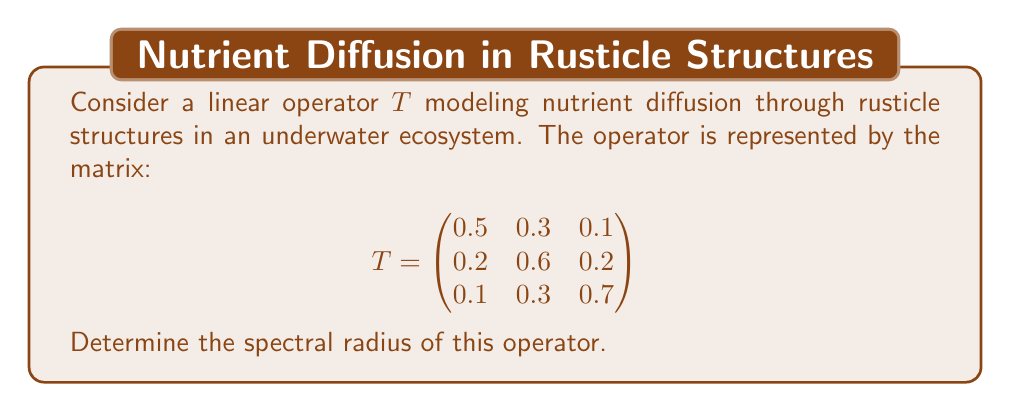Can you solve this math problem? To find the spectral radius of the linear operator $T$, we follow these steps:

1) The spectral radius is the maximum of the absolute values of the eigenvalues of $T$.

2) To find the eigenvalues, we solve the characteristic equation:
   $$\det(T - \lambda I) = 0$$

3) Expanding this determinant:
   $$\begin{vmatrix}
   0.5-\lambda & 0.3 & 0.1 \\
   0.2 & 0.6-\lambda & 0.2 \\
   0.1 & 0.3 & 0.7-\lambda
   \end{vmatrix} = 0$$

4) This expands to:
   $$(0.5-\lambda)(0.6-\lambda)(0.7-\lambda) - 0.3 \cdot 0.2 \cdot 0.1 - 0.1 \cdot 0.2 \cdot 0.3 - (0.5-\lambda) \cdot 0.2 \cdot 0.3 - 0.1 \cdot (0.6-\lambda) \cdot 0.1 - 0.3 \cdot 0.2 \cdot (0.7-\lambda) = 0$$

5) Simplifying:
   $$-\lambda^3 + 1.8\lambda^2 - 0.98\lambda + 0.162 = 0$$

6) This cubic equation can be solved using numerical methods. The eigenvalues are approximately:
   $$\lambda_1 \approx 0.9962, \lambda_2 \approx 0.4019, \lambda_3 \approx 0.4019$$

7) The spectral radius is the maximum absolute value of these eigenvalues:
   $$\rho(T) = \max(|\lambda_1|, |\lambda_2|, |\lambda_3|) \approx 0.9962$$
Answer: $0.9962$ 